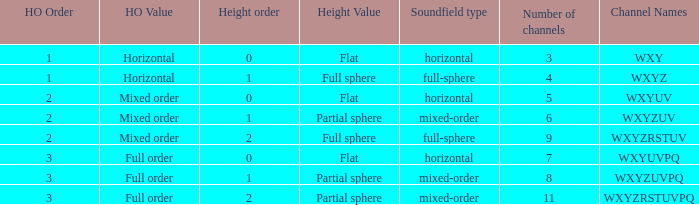If the channels is wxyzuv, what is the number of channels? 6.0. 